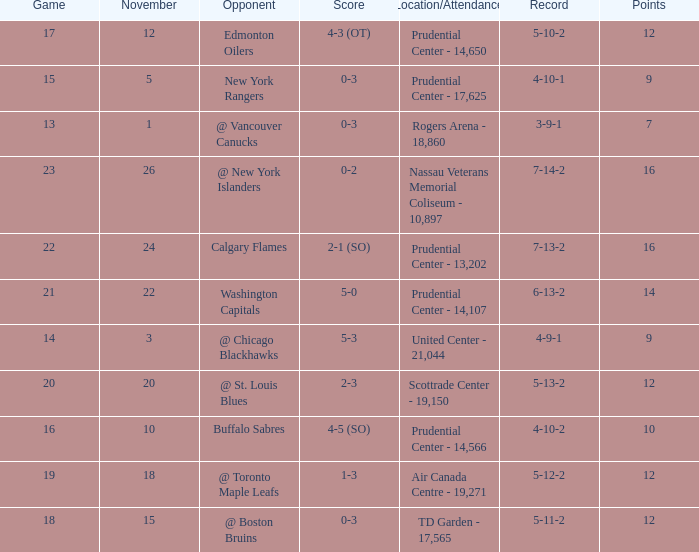Who was the opponent where the game is 14? @ Chicago Blackhawks. Would you mind parsing the complete table? {'header': ['Game', 'November', 'Opponent', 'Score', 'Location/Attendance', 'Record', 'Points'], 'rows': [['17', '12', 'Edmonton Oilers', '4-3 (OT)', 'Prudential Center - 14,650', '5-10-2', '12'], ['15', '5', 'New York Rangers', '0-3', 'Prudential Center - 17,625', '4-10-1', '9'], ['13', '1', '@ Vancouver Canucks', '0-3', 'Rogers Arena - 18,860', '3-9-1', '7'], ['23', '26', '@ New York Islanders', '0-2', 'Nassau Veterans Memorial Coliseum - 10,897', '7-14-2', '16'], ['22', '24', 'Calgary Flames', '2-1 (SO)', 'Prudential Center - 13,202', '7-13-2', '16'], ['21', '22', 'Washington Capitals', '5-0', 'Prudential Center - 14,107', '6-13-2', '14'], ['14', '3', '@ Chicago Blackhawks', '5-3', 'United Center - 21,044', '4-9-1', '9'], ['20', '20', '@ St. Louis Blues', '2-3', 'Scottrade Center - 19,150', '5-13-2', '12'], ['16', '10', 'Buffalo Sabres', '4-5 (SO)', 'Prudential Center - 14,566', '4-10-2', '10'], ['19', '18', '@ Toronto Maple Leafs', '1-3', 'Air Canada Centre - 19,271', '5-12-2', '12'], ['18', '15', '@ Boston Bruins', '0-3', 'TD Garden - 17,565', '5-11-2', '12']]} 